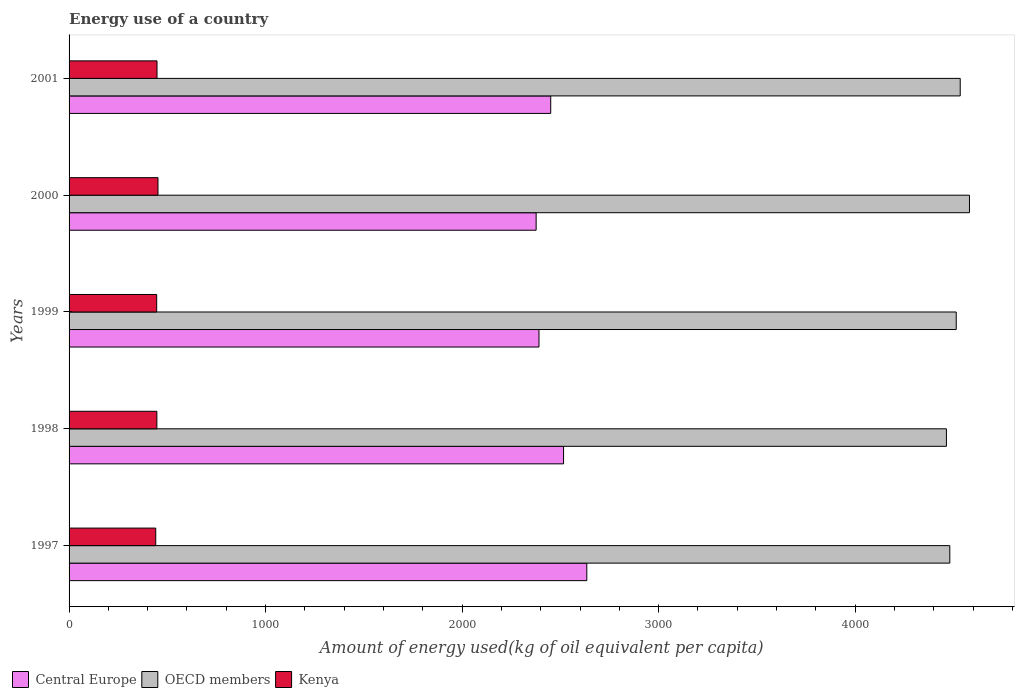How many different coloured bars are there?
Your answer should be very brief. 3. Are the number of bars per tick equal to the number of legend labels?
Provide a short and direct response. Yes. Are the number of bars on each tick of the Y-axis equal?
Your answer should be very brief. Yes. How many bars are there on the 3rd tick from the top?
Make the answer very short. 3. What is the amount of energy used in in Central Europe in 1999?
Provide a succinct answer. 2391.1. Across all years, what is the maximum amount of energy used in in OECD members?
Offer a very short reply. 4581.57. Across all years, what is the minimum amount of energy used in in Kenya?
Give a very brief answer. 441.01. What is the total amount of energy used in in OECD members in the graph?
Offer a terse response. 2.26e+04. What is the difference between the amount of energy used in in Central Europe in 1998 and that in 1999?
Give a very brief answer. 125.05. What is the difference between the amount of energy used in in OECD members in 2000 and the amount of energy used in in Central Europe in 1998?
Offer a terse response. 2065.42. What is the average amount of energy used in in Central Europe per year?
Your answer should be very brief. 2473.81. In the year 2000, what is the difference between the amount of energy used in in Central Europe and amount of energy used in in OECD members?
Ensure brevity in your answer.  -2204.92. What is the ratio of the amount of energy used in in Kenya in 1997 to that in 2000?
Offer a terse response. 0.97. Is the difference between the amount of energy used in in Central Europe in 1998 and 2001 greater than the difference between the amount of energy used in in OECD members in 1998 and 2001?
Your response must be concise. Yes. What is the difference between the highest and the second highest amount of energy used in in Kenya?
Offer a very short reply. 4.91. What is the difference between the highest and the lowest amount of energy used in in Central Europe?
Offer a terse response. 257.69. In how many years, is the amount of energy used in in Central Europe greater than the average amount of energy used in in Central Europe taken over all years?
Make the answer very short. 2. Is the sum of the amount of energy used in in OECD members in 1997 and 2000 greater than the maximum amount of energy used in in Kenya across all years?
Provide a short and direct response. Yes. How many bars are there?
Make the answer very short. 15. How many legend labels are there?
Your answer should be very brief. 3. What is the title of the graph?
Your answer should be compact. Energy use of a country. What is the label or title of the X-axis?
Keep it short and to the point. Amount of energy used(kg of oil equivalent per capita). What is the Amount of energy used(kg of oil equivalent per capita) of Central Europe in 1997?
Your answer should be very brief. 2634.35. What is the Amount of energy used(kg of oil equivalent per capita) of OECD members in 1997?
Your response must be concise. 4481.53. What is the Amount of energy used(kg of oil equivalent per capita) of Kenya in 1997?
Ensure brevity in your answer.  441.01. What is the Amount of energy used(kg of oil equivalent per capita) in Central Europe in 1998?
Keep it short and to the point. 2516.15. What is the Amount of energy used(kg of oil equivalent per capita) of OECD members in 1998?
Provide a succinct answer. 4464.27. What is the Amount of energy used(kg of oil equivalent per capita) in Kenya in 1998?
Your answer should be compact. 446.78. What is the Amount of energy used(kg of oil equivalent per capita) in Central Europe in 1999?
Your response must be concise. 2391.1. What is the Amount of energy used(kg of oil equivalent per capita) in OECD members in 1999?
Your answer should be very brief. 4514.18. What is the Amount of energy used(kg of oil equivalent per capita) in Kenya in 1999?
Ensure brevity in your answer.  445.84. What is the Amount of energy used(kg of oil equivalent per capita) of Central Europe in 2000?
Make the answer very short. 2376.65. What is the Amount of energy used(kg of oil equivalent per capita) in OECD members in 2000?
Your answer should be compact. 4581.57. What is the Amount of energy used(kg of oil equivalent per capita) of Kenya in 2000?
Keep it short and to the point. 452.4. What is the Amount of energy used(kg of oil equivalent per capita) in Central Europe in 2001?
Provide a short and direct response. 2450.82. What is the Amount of energy used(kg of oil equivalent per capita) of OECD members in 2001?
Provide a short and direct response. 4534.5. What is the Amount of energy used(kg of oil equivalent per capita) of Kenya in 2001?
Your answer should be very brief. 447.49. Across all years, what is the maximum Amount of energy used(kg of oil equivalent per capita) in Central Europe?
Make the answer very short. 2634.35. Across all years, what is the maximum Amount of energy used(kg of oil equivalent per capita) of OECD members?
Provide a succinct answer. 4581.57. Across all years, what is the maximum Amount of energy used(kg of oil equivalent per capita) of Kenya?
Provide a succinct answer. 452.4. Across all years, what is the minimum Amount of energy used(kg of oil equivalent per capita) of Central Europe?
Offer a terse response. 2376.65. Across all years, what is the minimum Amount of energy used(kg of oil equivalent per capita) of OECD members?
Provide a succinct answer. 4464.27. Across all years, what is the minimum Amount of energy used(kg of oil equivalent per capita) in Kenya?
Keep it short and to the point. 441.01. What is the total Amount of energy used(kg of oil equivalent per capita) in Central Europe in the graph?
Provide a succinct answer. 1.24e+04. What is the total Amount of energy used(kg of oil equivalent per capita) of OECD members in the graph?
Your answer should be compact. 2.26e+04. What is the total Amount of energy used(kg of oil equivalent per capita) in Kenya in the graph?
Keep it short and to the point. 2233.52. What is the difference between the Amount of energy used(kg of oil equivalent per capita) in Central Europe in 1997 and that in 1998?
Provide a succinct answer. 118.2. What is the difference between the Amount of energy used(kg of oil equivalent per capita) in OECD members in 1997 and that in 1998?
Make the answer very short. 17.26. What is the difference between the Amount of energy used(kg of oil equivalent per capita) of Kenya in 1997 and that in 1998?
Your answer should be very brief. -5.77. What is the difference between the Amount of energy used(kg of oil equivalent per capita) in Central Europe in 1997 and that in 1999?
Provide a short and direct response. 243.25. What is the difference between the Amount of energy used(kg of oil equivalent per capita) of OECD members in 1997 and that in 1999?
Your answer should be compact. -32.65. What is the difference between the Amount of energy used(kg of oil equivalent per capita) of Kenya in 1997 and that in 1999?
Give a very brief answer. -4.83. What is the difference between the Amount of energy used(kg of oil equivalent per capita) in Central Europe in 1997 and that in 2000?
Your answer should be very brief. 257.69. What is the difference between the Amount of energy used(kg of oil equivalent per capita) of OECD members in 1997 and that in 2000?
Your answer should be compact. -100.04. What is the difference between the Amount of energy used(kg of oil equivalent per capita) of Kenya in 1997 and that in 2000?
Your answer should be very brief. -11.4. What is the difference between the Amount of energy used(kg of oil equivalent per capita) in Central Europe in 1997 and that in 2001?
Provide a short and direct response. 183.53. What is the difference between the Amount of energy used(kg of oil equivalent per capita) of OECD members in 1997 and that in 2001?
Provide a short and direct response. -52.97. What is the difference between the Amount of energy used(kg of oil equivalent per capita) of Kenya in 1997 and that in 2001?
Keep it short and to the point. -6.49. What is the difference between the Amount of energy used(kg of oil equivalent per capita) of Central Europe in 1998 and that in 1999?
Provide a short and direct response. 125.05. What is the difference between the Amount of energy used(kg of oil equivalent per capita) of OECD members in 1998 and that in 1999?
Ensure brevity in your answer.  -49.91. What is the difference between the Amount of energy used(kg of oil equivalent per capita) in Kenya in 1998 and that in 1999?
Give a very brief answer. 0.93. What is the difference between the Amount of energy used(kg of oil equivalent per capita) of Central Europe in 1998 and that in 2000?
Your response must be concise. 139.5. What is the difference between the Amount of energy used(kg of oil equivalent per capita) in OECD members in 1998 and that in 2000?
Keep it short and to the point. -117.3. What is the difference between the Amount of energy used(kg of oil equivalent per capita) in Kenya in 1998 and that in 2000?
Offer a terse response. -5.63. What is the difference between the Amount of energy used(kg of oil equivalent per capita) in Central Europe in 1998 and that in 2001?
Offer a very short reply. 65.33. What is the difference between the Amount of energy used(kg of oil equivalent per capita) of OECD members in 1998 and that in 2001?
Ensure brevity in your answer.  -70.23. What is the difference between the Amount of energy used(kg of oil equivalent per capita) of Kenya in 1998 and that in 2001?
Give a very brief answer. -0.72. What is the difference between the Amount of energy used(kg of oil equivalent per capita) in Central Europe in 1999 and that in 2000?
Provide a short and direct response. 14.45. What is the difference between the Amount of energy used(kg of oil equivalent per capita) of OECD members in 1999 and that in 2000?
Offer a terse response. -67.39. What is the difference between the Amount of energy used(kg of oil equivalent per capita) in Kenya in 1999 and that in 2000?
Ensure brevity in your answer.  -6.56. What is the difference between the Amount of energy used(kg of oil equivalent per capita) of Central Europe in 1999 and that in 2001?
Give a very brief answer. -59.72. What is the difference between the Amount of energy used(kg of oil equivalent per capita) of OECD members in 1999 and that in 2001?
Offer a very short reply. -20.32. What is the difference between the Amount of energy used(kg of oil equivalent per capita) in Kenya in 1999 and that in 2001?
Provide a succinct answer. -1.65. What is the difference between the Amount of energy used(kg of oil equivalent per capita) of Central Europe in 2000 and that in 2001?
Provide a short and direct response. -74.17. What is the difference between the Amount of energy used(kg of oil equivalent per capita) of OECD members in 2000 and that in 2001?
Ensure brevity in your answer.  47.07. What is the difference between the Amount of energy used(kg of oil equivalent per capita) of Kenya in 2000 and that in 2001?
Give a very brief answer. 4.91. What is the difference between the Amount of energy used(kg of oil equivalent per capita) of Central Europe in 1997 and the Amount of energy used(kg of oil equivalent per capita) of OECD members in 1998?
Keep it short and to the point. -1829.92. What is the difference between the Amount of energy used(kg of oil equivalent per capita) in Central Europe in 1997 and the Amount of energy used(kg of oil equivalent per capita) in Kenya in 1998?
Give a very brief answer. 2187.57. What is the difference between the Amount of energy used(kg of oil equivalent per capita) of OECD members in 1997 and the Amount of energy used(kg of oil equivalent per capita) of Kenya in 1998?
Your response must be concise. 4034.75. What is the difference between the Amount of energy used(kg of oil equivalent per capita) of Central Europe in 1997 and the Amount of energy used(kg of oil equivalent per capita) of OECD members in 1999?
Provide a short and direct response. -1879.84. What is the difference between the Amount of energy used(kg of oil equivalent per capita) in Central Europe in 1997 and the Amount of energy used(kg of oil equivalent per capita) in Kenya in 1999?
Provide a succinct answer. 2188.5. What is the difference between the Amount of energy used(kg of oil equivalent per capita) of OECD members in 1997 and the Amount of energy used(kg of oil equivalent per capita) of Kenya in 1999?
Ensure brevity in your answer.  4035.69. What is the difference between the Amount of energy used(kg of oil equivalent per capita) in Central Europe in 1997 and the Amount of energy used(kg of oil equivalent per capita) in OECD members in 2000?
Your answer should be compact. -1947.22. What is the difference between the Amount of energy used(kg of oil equivalent per capita) in Central Europe in 1997 and the Amount of energy used(kg of oil equivalent per capita) in Kenya in 2000?
Provide a succinct answer. 2181.94. What is the difference between the Amount of energy used(kg of oil equivalent per capita) in OECD members in 1997 and the Amount of energy used(kg of oil equivalent per capita) in Kenya in 2000?
Offer a terse response. 4029.13. What is the difference between the Amount of energy used(kg of oil equivalent per capita) of Central Europe in 1997 and the Amount of energy used(kg of oil equivalent per capita) of OECD members in 2001?
Provide a succinct answer. -1900.16. What is the difference between the Amount of energy used(kg of oil equivalent per capita) of Central Europe in 1997 and the Amount of energy used(kg of oil equivalent per capita) of Kenya in 2001?
Your answer should be very brief. 2186.85. What is the difference between the Amount of energy used(kg of oil equivalent per capita) in OECD members in 1997 and the Amount of energy used(kg of oil equivalent per capita) in Kenya in 2001?
Give a very brief answer. 4034.03. What is the difference between the Amount of energy used(kg of oil equivalent per capita) of Central Europe in 1998 and the Amount of energy used(kg of oil equivalent per capita) of OECD members in 1999?
Make the answer very short. -1998.04. What is the difference between the Amount of energy used(kg of oil equivalent per capita) of Central Europe in 1998 and the Amount of energy used(kg of oil equivalent per capita) of Kenya in 1999?
Your response must be concise. 2070.3. What is the difference between the Amount of energy used(kg of oil equivalent per capita) of OECD members in 1998 and the Amount of energy used(kg of oil equivalent per capita) of Kenya in 1999?
Your answer should be compact. 4018.43. What is the difference between the Amount of energy used(kg of oil equivalent per capita) in Central Europe in 1998 and the Amount of energy used(kg of oil equivalent per capita) in OECD members in 2000?
Your answer should be compact. -2065.42. What is the difference between the Amount of energy used(kg of oil equivalent per capita) of Central Europe in 1998 and the Amount of energy used(kg of oil equivalent per capita) of Kenya in 2000?
Offer a very short reply. 2063.74. What is the difference between the Amount of energy used(kg of oil equivalent per capita) in OECD members in 1998 and the Amount of energy used(kg of oil equivalent per capita) in Kenya in 2000?
Ensure brevity in your answer.  4011.86. What is the difference between the Amount of energy used(kg of oil equivalent per capita) of Central Europe in 1998 and the Amount of energy used(kg of oil equivalent per capita) of OECD members in 2001?
Provide a short and direct response. -2018.35. What is the difference between the Amount of energy used(kg of oil equivalent per capita) in Central Europe in 1998 and the Amount of energy used(kg of oil equivalent per capita) in Kenya in 2001?
Make the answer very short. 2068.65. What is the difference between the Amount of energy used(kg of oil equivalent per capita) of OECD members in 1998 and the Amount of energy used(kg of oil equivalent per capita) of Kenya in 2001?
Offer a very short reply. 4016.77. What is the difference between the Amount of energy used(kg of oil equivalent per capita) of Central Europe in 1999 and the Amount of energy used(kg of oil equivalent per capita) of OECD members in 2000?
Provide a succinct answer. -2190.47. What is the difference between the Amount of energy used(kg of oil equivalent per capita) of Central Europe in 1999 and the Amount of energy used(kg of oil equivalent per capita) of Kenya in 2000?
Give a very brief answer. 1938.69. What is the difference between the Amount of energy used(kg of oil equivalent per capita) in OECD members in 1999 and the Amount of energy used(kg of oil equivalent per capita) in Kenya in 2000?
Make the answer very short. 4061.78. What is the difference between the Amount of energy used(kg of oil equivalent per capita) in Central Europe in 1999 and the Amount of energy used(kg of oil equivalent per capita) in OECD members in 2001?
Provide a succinct answer. -2143.4. What is the difference between the Amount of energy used(kg of oil equivalent per capita) of Central Europe in 1999 and the Amount of energy used(kg of oil equivalent per capita) of Kenya in 2001?
Your answer should be compact. 1943.6. What is the difference between the Amount of energy used(kg of oil equivalent per capita) of OECD members in 1999 and the Amount of energy used(kg of oil equivalent per capita) of Kenya in 2001?
Provide a succinct answer. 4066.69. What is the difference between the Amount of energy used(kg of oil equivalent per capita) in Central Europe in 2000 and the Amount of energy used(kg of oil equivalent per capita) in OECD members in 2001?
Provide a succinct answer. -2157.85. What is the difference between the Amount of energy used(kg of oil equivalent per capita) of Central Europe in 2000 and the Amount of energy used(kg of oil equivalent per capita) of Kenya in 2001?
Make the answer very short. 1929.16. What is the difference between the Amount of energy used(kg of oil equivalent per capita) in OECD members in 2000 and the Amount of energy used(kg of oil equivalent per capita) in Kenya in 2001?
Provide a short and direct response. 4134.07. What is the average Amount of energy used(kg of oil equivalent per capita) of Central Europe per year?
Make the answer very short. 2473.81. What is the average Amount of energy used(kg of oil equivalent per capita) in OECD members per year?
Make the answer very short. 4515.21. What is the average Amount of energy used(kg of oil equivalent per capita) in Kenya per year?
Your response must be concise. 446.7. In the year 1997, what is the difference between the Amount of energy used(kg of oil equivalent per capita) of Central Europe and Amount of energy used(kg of oil equivalent per capita) of OECD members?
Your response must be concise. -1847.18. In the year 1997, what is the difference between the Amount of energy used(kg of oil equivalent per capita) of Central Europe and Amount of energy used(kg of oil equivalent per capita) of Kenya?
Provide a succinct answer. 2193.34. In the year 1997, what is the difference between the Amount of energy used(kg of oil equivalent per capita) in OECD members and Amount of energy used(kg of oil equivalent per capita) in Kenya?
Make the answer very short. 4040.52. In the year 1998, what is the difference between the Amount of energy used(kg of oil equivalent per capita) of Central Europe and Amount of energy used(kg of oil equivalent per capita) of OECD members?
Provide a short and direct response. -1948.12. In the year 1998, what is the difference between the Amount of energy used(kg of oil equivalent per capita) in Central Europe and Amount of energy used(kg of oil equivalent per capita) in Kenya?
Your response must be concise. 2069.37. In the year 1998, what is the difference between the Amount of energy used(kg of oil equivalent per capita) in OECD members and Amount of energy used(kg of oil equivalent per capita) in Kenya?
Keep it short and to the point. 4017.49. In the year 1999, what is the difference between the Amount of energy used(kg of oil equivalent per capita) in Central Europe and Amount of energy used(kg of oil equivalent per capita) in OECD members?
Make the answer very short. -2123.08. In the year 1999, what is the difference between the Amount of energy used(kg of oil equivalent per capita) of Central Europe and Amount of energy used(kg of oil equivalent per capita) of Kenya?
Make the answer very short. 1945.26. In the year 1999, what is the difference between the Amount of energy used(kg of oil equivalent per capita) in OECD members and Amount of energy used(kg of oil equivalent per capita) in Kenya?
Provide a short and direct response. 4068.34. In the year 2000, what is the difference between the Amount of energy used(kg of oil equivalent per capita) of Central Europe and Amount of energy used(kg of oil equivalent per capita) of OECD members?
Ensure brevity in your answer.  -2204.92. In the year 2000, what is the difference between the Amount of energy used(kg of oil equivalent per capita) in Central Europe and Amount of energy used(kg of oil equivalent per capita) in Kenya?
Offer a terse response. 1924.25. In the year 2000, what is the difference between the Amount of energy used(kg of oil equivalent per capita) of OECD members and Amount of energy used(kg of oil equivalent per capita) of Kenya?
Ensure brevity in your answer.  4129.17. In the year 2001, what is the difference between the Amount of energy used(kg of oil equivalent per capita) of Central Europe and Amount of energy used(kg of oil equivalent per capita) of OECD members?
Keep it short and to the point. -2083.68. In the year 2001, what is the difference between the Amount of energy used(kg of oil equivalent per capita) of Central Europe and Amount of energy used(kg of oil equivalent per capita) of Kenya?
Your answer should be compact. 2003.33. In the year 2001, what is the difference between the Amount of energy used(kg of oil equivalent per capita) in OECD members and Amount of energy used(kg of oil equivalent per capita) in Kenya?
Offer a terse response. 4087.01. What is the ratio of the Amount of energy used(kg of oil equivalent per capita) in Central Europe in 1997 to that in 1998?
Provide a short and direct response. 1.05. What is the ratio of the Amount of energy used(kg of oil equivalent per capita) in Kenya in 1997 to that in 1998?
Your response must be concise. 0.99. What is the ratio of the Amount of energy used(kg of oil equivalent per capita) in Central Europe in 1997 to that in 1999?
Offer a very short reply. 1.1. What is the ratio of the Amount of energy used(kg of oil equivalent per capita) in OECD members in 1997 to that in 1999?
Provide a short and direct response. 0.99. What is the ratio of the Amount of energy used(kg of oil equivalent per capita) of Central Europe in 1997 to that in 2000?
Make the answer very short. 1.11. What is the ratio of the Amount of energy used(kg of oil equivalent per capita) of OECD members in 1997 to that in 2000?
Ensure brevity in your answer.  0.98. What is the ratio of the Amount of energy used(kg of oil equivalent per capita) of Kenya in 1997 to that in 2000?
Provide a succinct answer. 0.97. What is the ratio of the Amount of energy used(kg of oil equivalent per capita) of Central Europe in 1997 to that in 2001?
Your answer should be very brief. 1.07. What is the ratio of the Amount of energy used(kg of oil equivalent per capita) in OECD members in 1997 to that in 2001?
Ensure brevity in your answer.  0.99. What is the ratio of the Amount of energy used(kg of oil equivalent per capita) of Kenya in 1997 to that in 2001?
Your answer should be very brief. 0.99. What is the ratio of the Amount of energy used(kg of oil equivalent per capita) of Central Europe in 1998 to that in 1999?
Offer a terse response. 1.05. What is the ratio of the Amount of energy used(kg of oil equivalent per capita) of OECD members in 1998 to that in 1999?
Your answer should be very brief. 0.99. What is the ratio of the Amount of energy used(kg of oil equivalent per capita) of Central Europe in 1998 to that in 2000?
Offer a very short reply. 1.06. What is the ratio of the Amount of energy used(kg of oil equivalent per capita) of OECD members in 1998 to that in 2000?
Offer a terse response. 0.97. What is the ratio of the Amount of energy used(kg of oil equivalent per capita) in Kenya in 1998 to that in 2000?
Your response must be concise. 0.99. What is the ratio of the Amount of energy used(kg of oil equivalent per capita) in Central Europe in 1998 to that in 2001?
Offer a very short reply. 1.03. What is the ratio of the Amount of energy used(kg of oil equivalent per capita) in OECD members in 1998 to that in 2001?
Give a very brief answer. 0.98. What is the ratio of the Amount of energy used(kg of oil equivalent per capita) of OECD members in 1999 to that in 2000?
Give a very brief answer. 0.99. What is the ratio of the Amount of energy used(kg of oil equivalent per capita) in Kenya in 1999 to that in 2000?
Keep it short and to the point. 0.99. What is the ratio of the Amount of energy used(kg of oil equivalent per capita) in Central Europe in 1999 to that in 2001?
Ensure brevity in your answer.  0.98. What is the ratio of the Amount of energy used(kg of oil equivalent per capita) in Central Europe in 2000 to that in 2001?
Your response must be concise. 0.97. What is the ratio of the Amount of energy used(kg of oil equivalent per capita) in OECD members in 2000 to that in 2001?
Ensure brevity in your answer.  1.01. What is the difference between the highest and the second highest Amount of energy used(kg of oil equivalent per capita) of Central Europe?
Make the answer very short. 118.2. What is the difference between the highest and the second highest Amount of energy used(kg of oil equivalent per capita) in OECD members?
Offer a terse response. 47.07. What is the difference between the highest and the second highest Amount of energy used(kg of oil equivalent per capita) in Kenya?
Your response must be concise. 4.91. What is the difference between the highest and the lowest Amount of energy used(kg of oil equivalent per capita) in Central Europe?
Give a very brief answer. 257.69. What is the difference between the highest and the lowest Amount of energy used(kg of oil equivalent per capita) in OECD members?
Ensure brevity in your answer.  117.3. What is the difference between the highest and the lowest Amount of energy used(kg of oil equivalent per capita) of Kenya?
Ensure brevity in your answer.  11.4. 